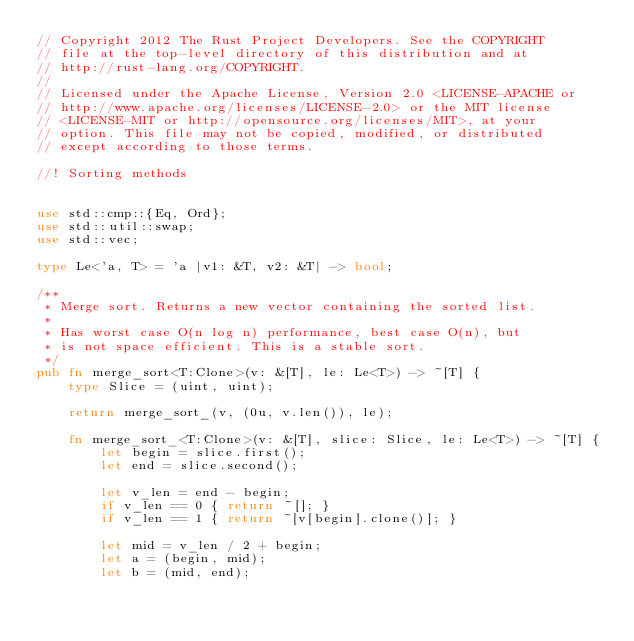<code> <loc_0><loc_0><loc_500><loc_500><_Rust_>// Copyright 2012 The Rust Project Developers. See the COPYRIGHT
// file at the top-level directory of this distribution and at
// http://rust-lang.org/COPYRIGHT.
//
// Licensed under the Apache License, Version 2.0 <LICENSE-APACHE or
// http://www.apache.org/licenses/LICENSE-2.0> or the MIT license
// <LICENSE-MIT or http://opensource.org/licenses/MIT>, at your
// option. This file may not be copied, modified, or distributed
// except according to those terms.

//! Sorting methods


use std::cmp::{Eq, Ord};
use std::util::swap;
use std::vec;

type Le<'a, T> = 'a |v1: &T, v2: &T| -> bool;

/**
 * Merge sort. Returns a new vector containing the sorted list.
 *
 * Has worst case O(n log n) performance, best case O(n), but
 * is not space efficient. This is a stable sort.
 */
pub fn merge_sort<T:Clone>(v: &[T], le: Le<T>) -> ~[T] {
    type Slice = (uint, uint);

    return merge_sort_(v, (0u, v.len()), le);

    fn merge_sort_<T:Clone>(v: &[T], slice: Slice, le: Le<T>) -> ~[T] {
        let begin = slice.first();
        let end = slice.second();

        let v_len = end - begin;
        if v_len == 0 { return ~[]; }
        if v_len == 1 { return ~[v[begin].clone()]; }

        let mid = v_len / 2 + begin;
        let a = (begin, mid);
        let b = (mid, end);</code> 